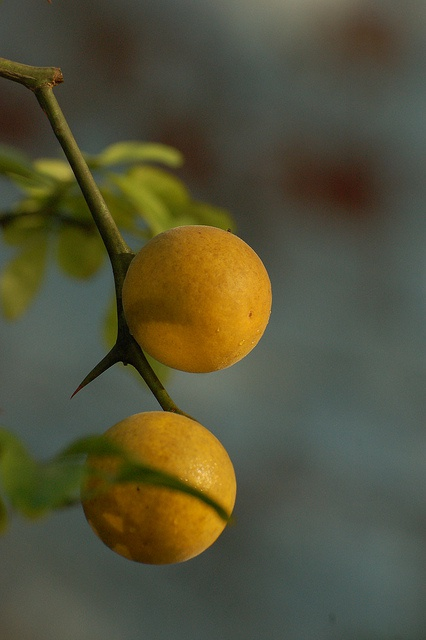Describe the objects in this image and their specific colors. I can see orange in darkgreen, olive, maroon, and orange tones and orange in darkgreen, olive, orange, and maroon tones in this image. 